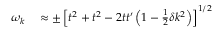Convert formula to latex. <formula><loc_0><loc_0><loc_500><loc_500>\begin{array} { r l } { \omega _ { k } } & \approx \pm \left [ t ^ { 2 } + t ^ { 2 } - 2 t t ^ { \prime } \left ( 1 - \frac { 1 } { 2 } \delta k ^ { 2 } \right ) \right ] ^ { 1 / 2 } } \end{array}</formula> 